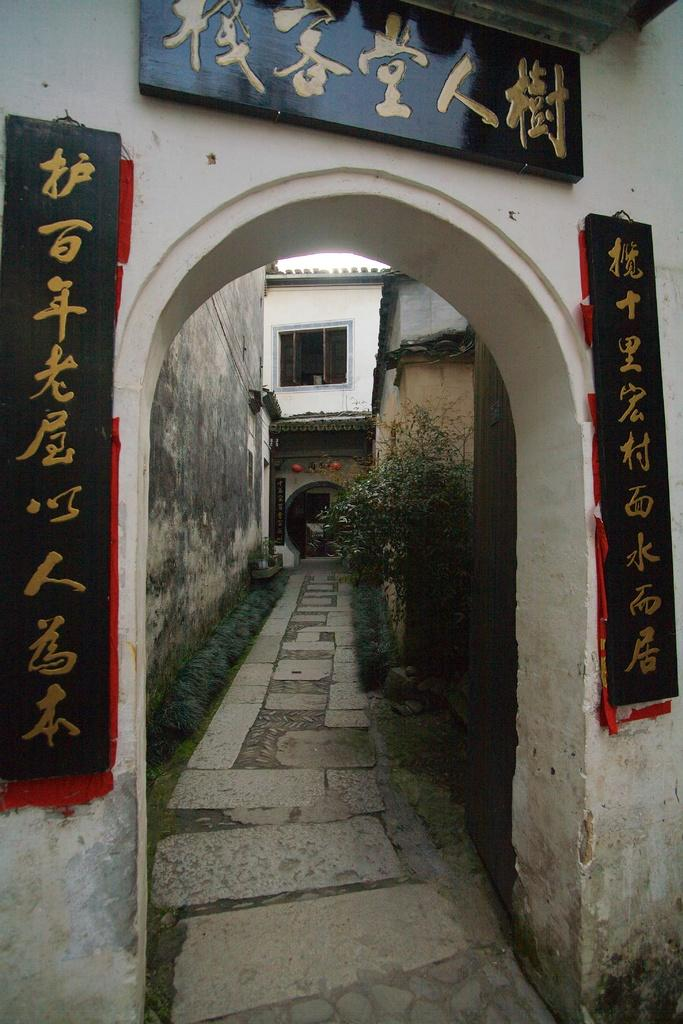What is the main structure in the center of the image? There is an arch in the center of the image. What else can be seen in the center of the image? There are banners in the center of the image. What can be seen in the background of the image? There is a building, a wall, a window, grass, and plants in the background of the image. How many pieces of beef are visible in the image? There is no beef present in the image. What type of spiders can be seen crawling on the plants in the image? There are no spiders present in the image; only plants are visible in the background. 